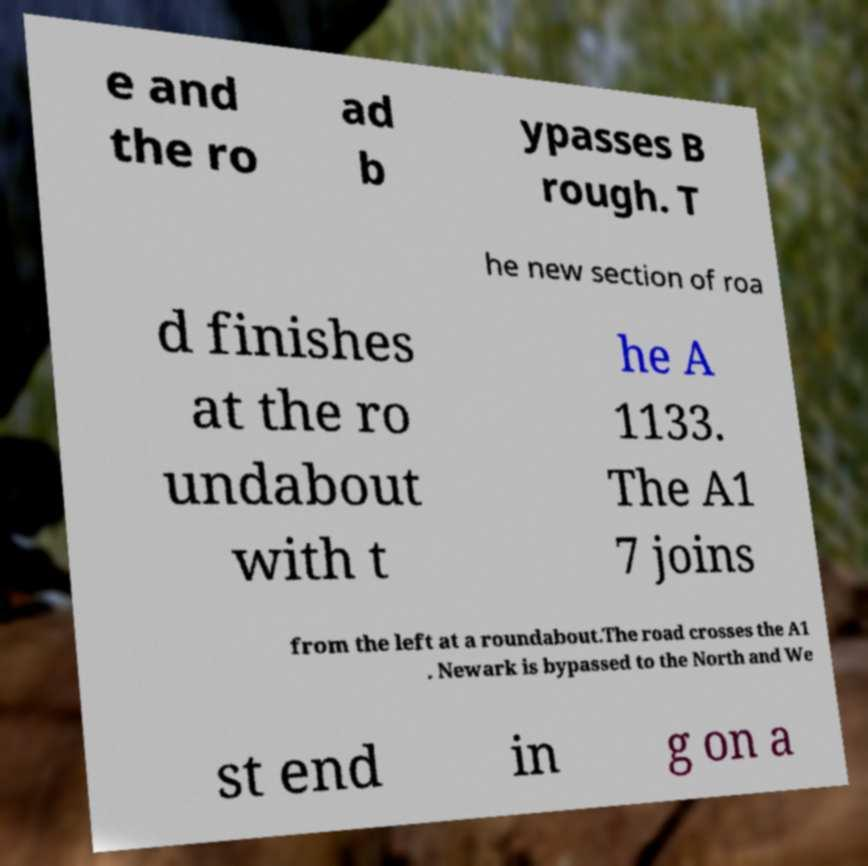Can you read and provide the text displayed in the image?This photo seems to have some interesting text. Can you extract and type it out for me? e and the ro ad b ypasses B rough. T he new section of roa d finishes at the ro undabout with t he A 1133. The A1 7 joins from the left at a roundabout.The road crosses the A1 . Newark is bypassed to the North and We st end in g on a 